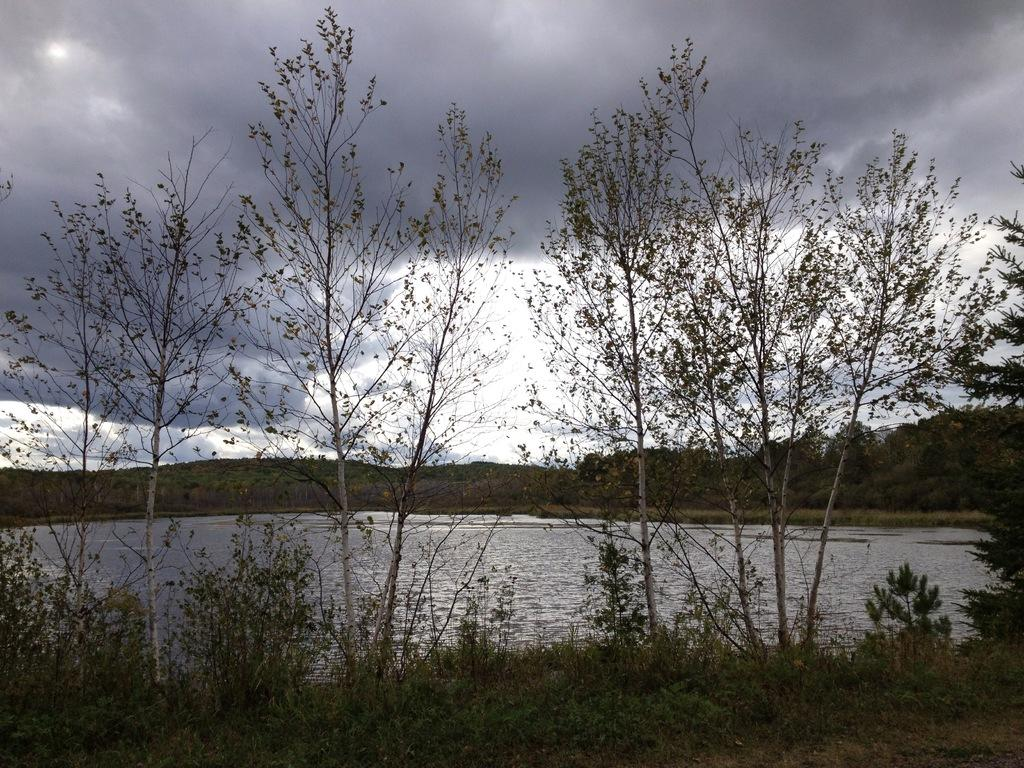What type of vegetation can be seen in the image? There are plants and trees in the image. What is the water surface visible in the image? There is a water surface visible in the image. What can be seen in the sky in the image? Clouds are present in the sky in the image. What type of cheese is floating on the water surface in the image? There is no cheese present in the image; it only features plants, trees, a water surface, and clouds in the sky. 